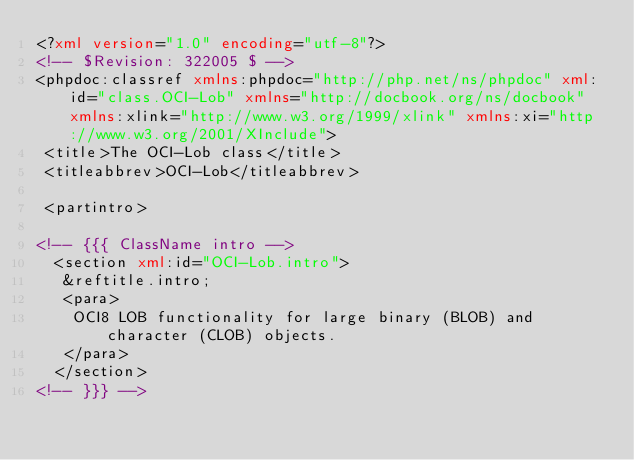<code> <loc_0><loc_0><loc_500><loc_500><_XML_><?xml version="1.0" encoding="utf-8"?>
<!-- $Revision: 322005 $ -->
<phpdoc:classref xmlns:phpdoc="http://php.net/ns/phpdoc" xml:id="class.OCI-Lob" xmlns="http://docbook.org/ns/docbook" xmlns:xlink="http://www.w3.org/1999/xlink" xmlns:xi="http://www.w3.org/2001/XInclude">
 <title>The OCI-Lob class</title>
 <titleabbrev>OCI-Lob</titleabbrev>
 
 <partintro>
 
<!-- {{{ ClassName intro -->
  <section xml:id="OCI-Lob.intro">
   &reftitle.intro;
   <para>
    OCI8 LOB functionality for large binary (BLOB) and character (CLOB) objects.
   </para>
  </section>
<!-- }}} -->
 </code> 